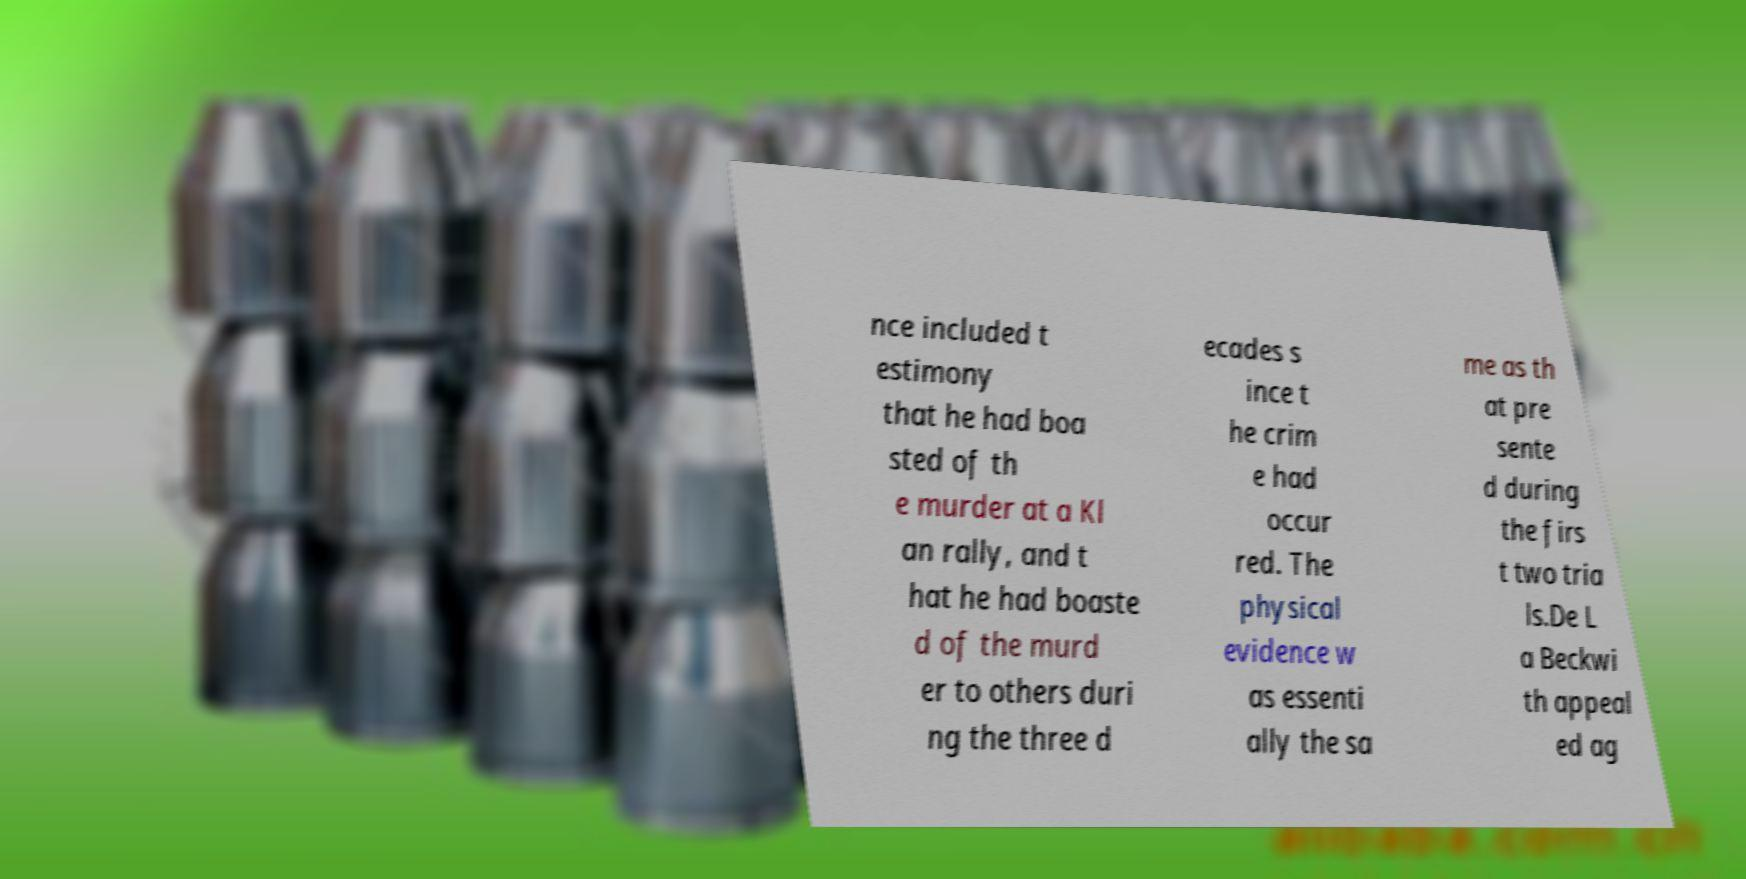I need the written content from this picture converted into text. Can you do that? nce included t estimony that he had boa sted of th e murder at a Kl an rally, and t hat he had boaste d of the murd er to others duri ng the three d ecades s ince t he crim e had occur red. The physical evidence w as essenti ally the sa me as th at pre sente d during the firs t two tria ls.De L a Beckwi th appeal ed ag 